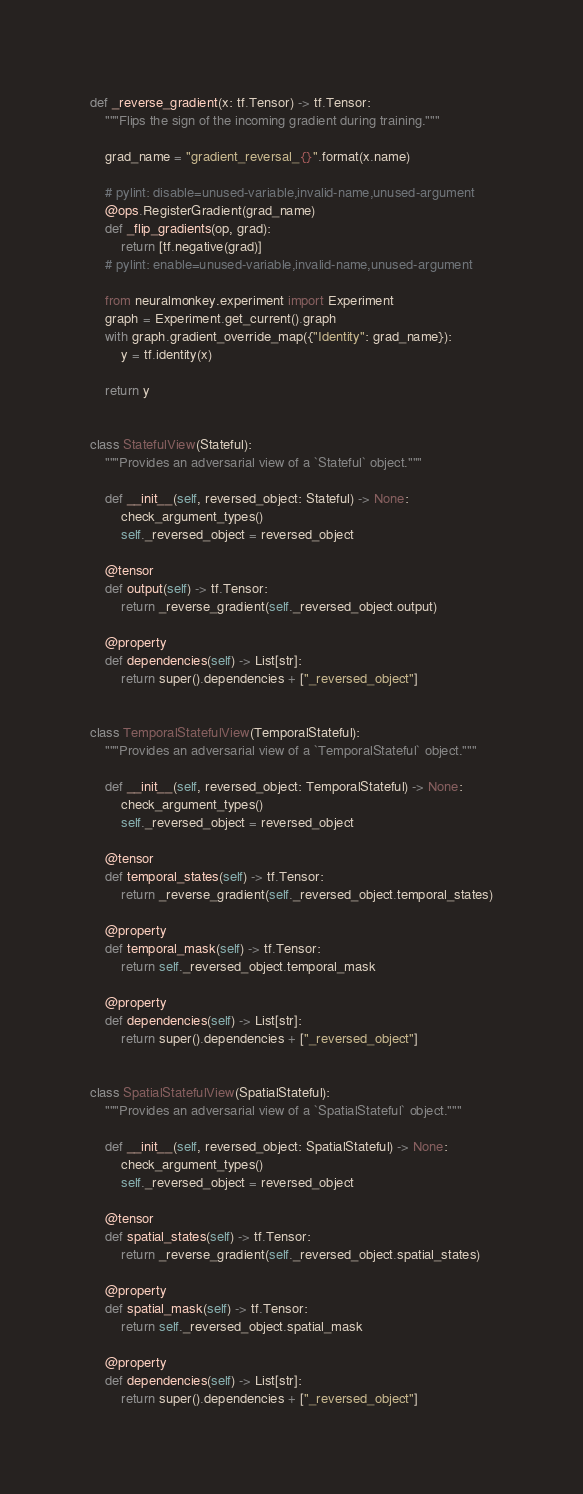<code> <loc_0><loc_0><loc_500><loc_500><_Python_>
def _reverse_gradient(x: tf.Tensor) -> tf.Tensor:
    """Flips the sign of the incoming gradient during training."""

    grad_name = "gradient_reversal_{}".format(x.name)

    # pylint: disable=unused-variable,invalid-name,unused-argument
    @ops.RegisterGradient(grad_name)
    def _flip_gradients(op, grad):
        return [tf.negative(grad)]
    # pylint: enable=unused-variable,invalid-name,unused-argument

    from neuralmonkey.experiment import Experiment
    graph = Experiment.get_current().graph
    with graph.gradient_override_map({"Identity": grad_name}):
        y = tf.identity(x)

    return y


class StatefulView(Stateful):
    """Provides an adversarial view of a `Stateful` object."""

    def __init__(self, reversed_object: Stateful) -> None:
        check_argument_types()
        self._reversed_object = reversed_object

    @tensor
    def output(self) -> tf.Tensor:
        return _reverse_gradient(self._reversed_object.output)

    @property
    def dependencies(self) -> List[str]:
        return super().dependencies + ["_reversed_object"]


class TemporalStatefulView(TemporalStateful):
    """Provides an adversarial view of a `TemporalStateful` object."""

    def __init__(self, reversed_object: TemporalStateful) -> None:
        check_argument_types()
        self._reversed_object = reversed_object

    @tensor
    def temporal_states(self) -> tf.Tensor:
        return _reverse_gradient(self._reversed_object.temporal_states)

    @property
    def temporal_mask(self) -> tf.Tensor:
        return self._reversed_object.temporal_mask

    @property
    def dependencies(self) -> List[str]:
        return super().dependencies + ["_reversed_object"]


class SpatialStatefulView(SpatialStateful):
    """Provides an adversarial view of a `SpatialStateful` object."""

    def __init__(self, reversed_object: SpatialStateful) -> None:
        check_argument_types()
        self._reversed_object = reversed_object

    @tensor
    def spatial_states(self) -> tf.Tensor:
        return _reverse_gradient(self._reversed_object.spatial_states)

    @property
    def spatial_mask(self) -> tf.Tensor:
        return self._reversed_object.spatial_mask

    @property
    def dependencies(self) -> List[str]:
        return super().dependencies + ["_reversed_object"]
</code> 